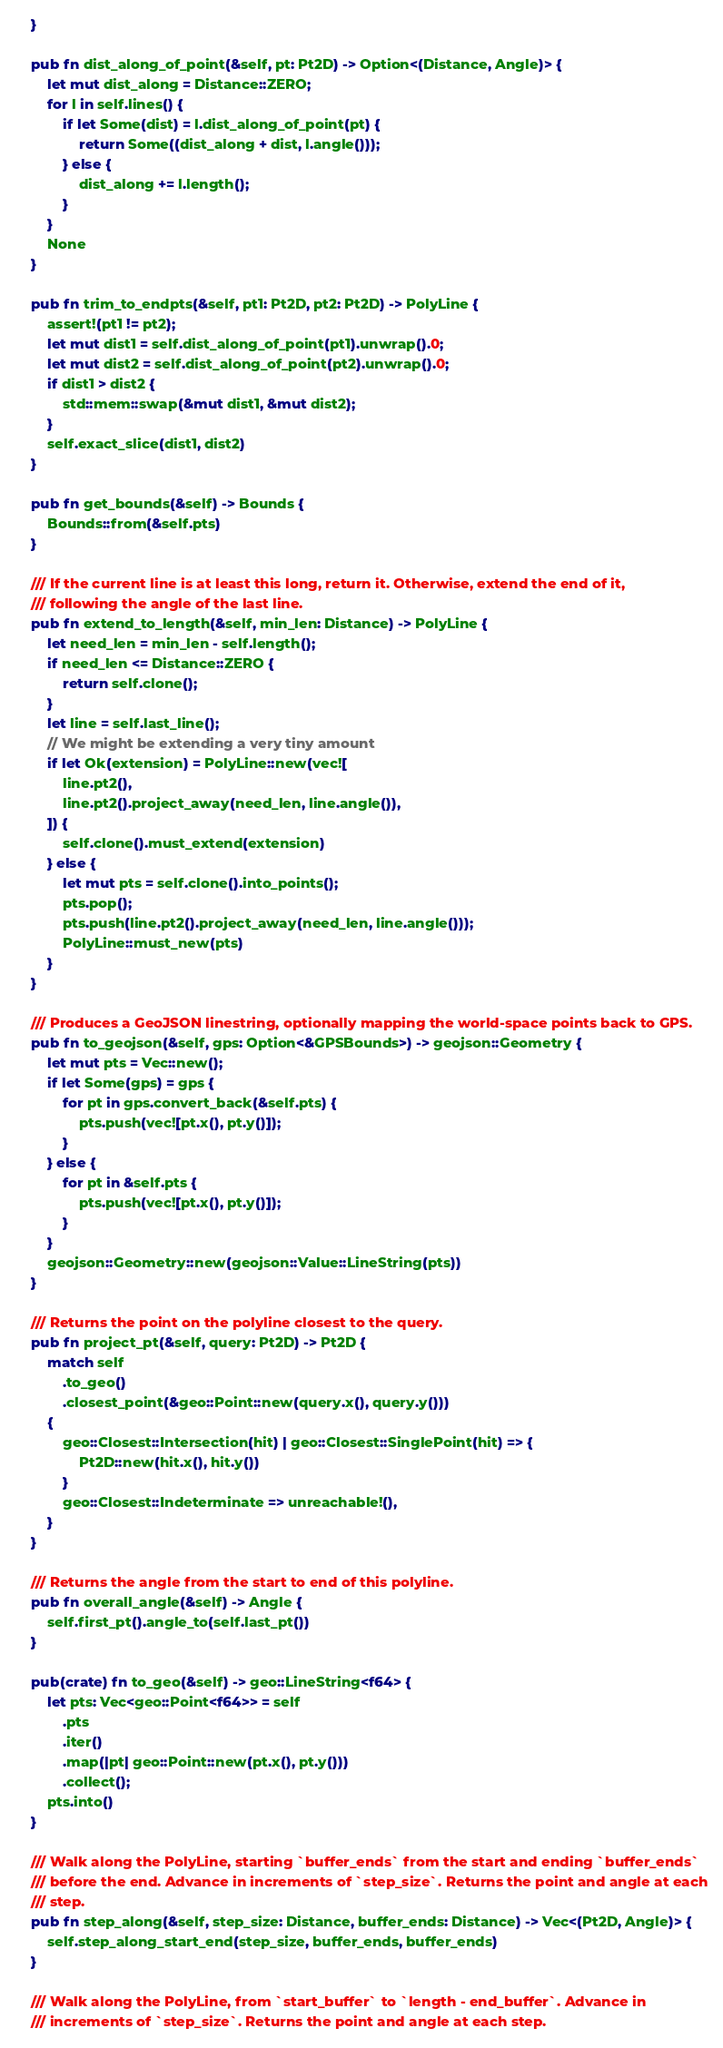<code> <loc_0><loc_0><loc_500><loc_500><_Rust_>    }

    pub fn dist_along_of_point(&self, pt: Pt2D) -> Option<(Distance, Angle)> {
        let mut dist_along = Distance::ZERO;
        for l in self.lines() {
            if let Some(dist) = l.dist_along_of_point(pt) {
                return Some((dist_along + dist, l.angle()));
            } else {
                dist_along += l.length();
            }
        }
        None
    }

    pub fn trim_to_endpts(&self, pt1: Pt2D, pt2: Pt2D) -> PolyLine {
        assert!(pt1 != pt2);
        let mut dist1 = self.dist_along_of_point(pt1).unwrap().0;
        let mut dist2 = self.dist_along_of_point(pt2).unwrap().0;
        if dist1 > dist2 {
            std::mem::swap(&mut dist1, &mut dist2);
        }
        self.exact_slice(dist1, dist2)
    }

    pub fn get_bounds(&self) -> Bounds {
        Bounds::from(&self.pts)
    }

    /// If the current line is at least this long, return it. Otherwise, extend the end of it,
    /// following the angle of the last line.
    pub fn extend_to_length(&self, min_len: Distance) -> PolyLine {
        let need_len = min_len - self.length();
        if need_len <= Distance::ZERO {
            return self.clone();
        }
        let line = self.last_line();
        // We might be extending a very tiny amount
        if let Ok(extension) = PolyLine::new(vec![
            line.pt2(),
            line.pt2().project_away(need_len, line.angle()),
        ]) {
            self.clone().must_extend(extension)
        } else {
            let mut pts = self.clone().into_points();
            pts.pop();
            pts.push(line.pt2().project_away(need_len, line.angle()));
            PolyLine::must_new(pts)
        }
    }

    /// Produces a GeoJSON linestring, optionally mapping the world-space points back to GPS.
    pub fn to_geojson(&self, gps: Option<&GPSBounds>) -> geojson::Geometry {
        let mut pts = Vec::new();
        if let Some(gps) = gps {
            for pt in gps.convert_back(&self.pts) {
                pts.push(vec![pt.x(), pt.y()]);
            }
        } else {
            for pt in &self.pts {
                pts.push(vec![pt.x(), pt.y()]);
            }
        }
        geojson::Geometry::new(geojson::Value::LineString(pts))
    }

    /// Returns the point on the polyline closest to the query.
    pub fn project_pt(&self, query: Pt2D) -> Pt2D {
        match self
            .to_geo()
            .closest_point(&geo::Point::new(query.x(), query.y()))
        {
            geo::Closest::Intersection(hit) | geo::Closest::SinglePoint(hit) => {
                Pt2D::new(hit.x(), hit.y())
            }
            geo::Closest::Indeterminate => unreachable!(),
        }
    }

    /// Returns the angle from the start to end of this polyline.
    pub fn overall_angle(&self) -> Angle {
        self.first_pt().angle_to(self.last_pt())
    }

    pub(crate) fn to_geo(&self) -> geo::LineString<f64> {
        let pts: Vec<geo::Point<f64>> = self
            .pts
            .iter()
            .map(|pt| geo::Point::new(pt.x(), pt.y()))
            .collect();
        pts.into()
    }

    /// Walk along the PolyLine, starting `buffer_ends` from the start and ending `buffer_ends`
    /// before the end. Advance in increments of `step_size`. Returns the point and angle at each
    /// step.
    pub fn step_along(&self, step_size: Distance, buffer_ends: Distance) -> Vec<(Pt2D, Angle)> {
        self.step_along_start_end(step_size, buffer_ends, buffer_ends)
    }

    /// Walk along the PolyLine, from `start_buffer` to `length - end_buffer`. Advance in
    /// increments of `step_size`. Returns the point and angle at each step.</code> 